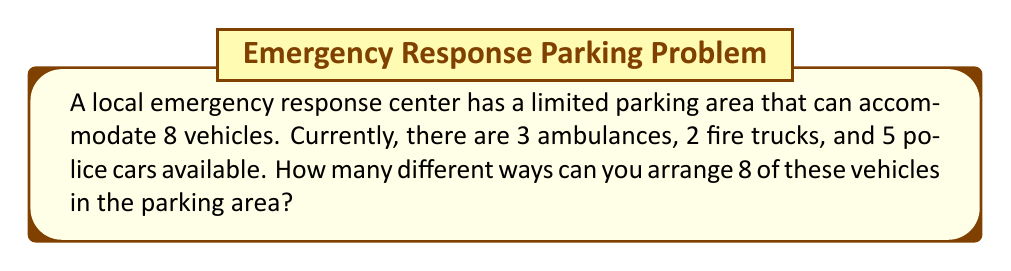Solve this math problem. Let's approach this step-by-step:

1) First, we need to choose which 8 vehicles out of the total 10 will be parked. This is a combination problem.

2) We can think of this as choosing how many of each type of vehicle to include:
   - We must choose 0 to 3 ambulances
   - 0 to 2 fire trucks
   - And enough police cars to make the total 8

3) Let's list all possible combinations:
   - 3 ambulances, 2 fire trucks, 3 police cars
   - 3 ambulances, 1 fire truck, 4 police cars
   - 3 ambulances, 0 fire trucks, 5 police cars
   - 2 ambulances, 2 fire trucks, 4 police cars
   - 2 ambulances, 1 fire truck, 5 police cars
   - 1 ambulance, 2 fire trucks, 5 police cars

4) There are 6 ways to choose which 8 vehicles will be parked.

5) For each of these 6 choices, we need to calculate how many ways we can arrange 8 vehicles. This is a permutation of 8 distinct objects, which is simply 8!.

6) Therefore, the total number of arrangements is:

   $$ 6 \times 8! = 6 \times 40,320 = 241,920 $$

This calculation gives us the total number of possible arrangements, considering both the selection of vehicles and their order in the parking area.
Answer: 241,920 different arrangements 